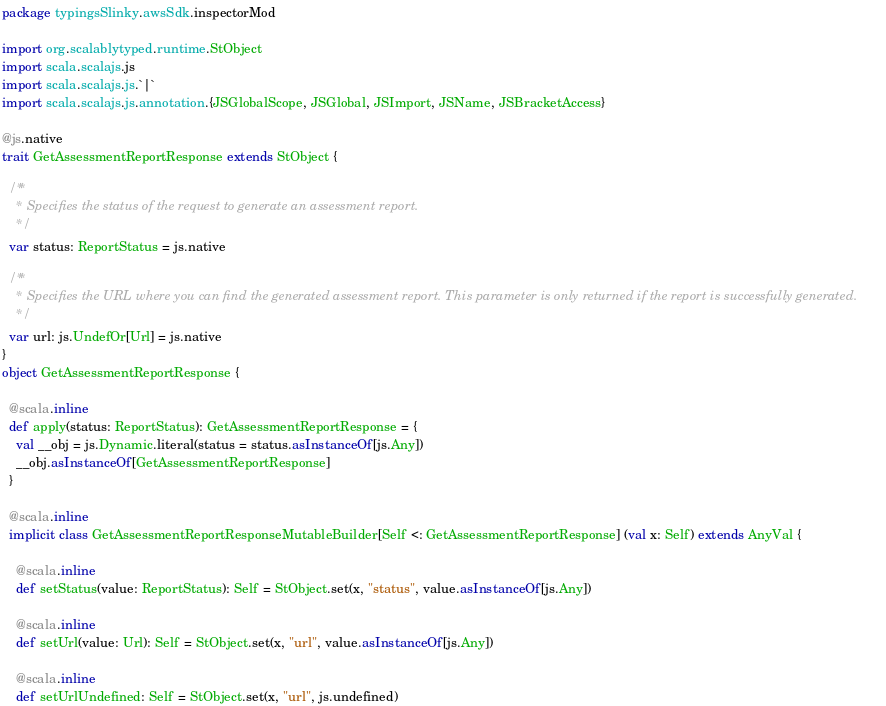<code> <loc_0><loc_0><loc_500><loc_500><_Scala_>package typingsSlinky.awsSdk.inspectorMod

import org.scalablytyped.runtime.StObject
import scala.scalajs.js
import scala.scalajs.js.`|`
import scala.scalajs.js.annotation.{JSGlobalScope, JSGlobal, JSImport, JSName, JSBracketAccess}

@js.native
trait GetAssessmentReportResponse extends StObject {
  
  /**
    * Specifies the status of the request to generate an assessment report. 
    */
  var status: ReportStatus = js.native
  
  /**
    * Specifies the URL where you can find the generated assessment report. This parameter is only returned if the report is successfully generated.
    */
  var url: js.UndefOr[Url] = js.native
}
object GetAssessmentReportResponse {
  
  @scala.inline
  def apply(status: ReportStatus): GetAssessmentReportResponse = {
    val __obj = js.Dynamic.literal(status = status.asInstanceOf[js.Any])
    __obj.asInstanceOf[GetAssessmentReportResponse]
  }
  
  @scala.inline
  implicit class GetAssessmentReportResponseMutableBuilder[Self <: GetAssessmentReportResponse] (val x: Self) extends AnyVal {
    
    @scala.inline
    def setStatus(value: ReportStatus): Self = StObject.set(x, "status", value.asInstanceOf[js.Any])
    
    @scala.inline
    def setUrl(value: Url): Self = StObject.set(x, "url", value.asInstanceOf[js.Any])
    
    @scala.inline
    def setUrlUndefined: Self = StObject.set(x, "url", js.undefined)</code> 